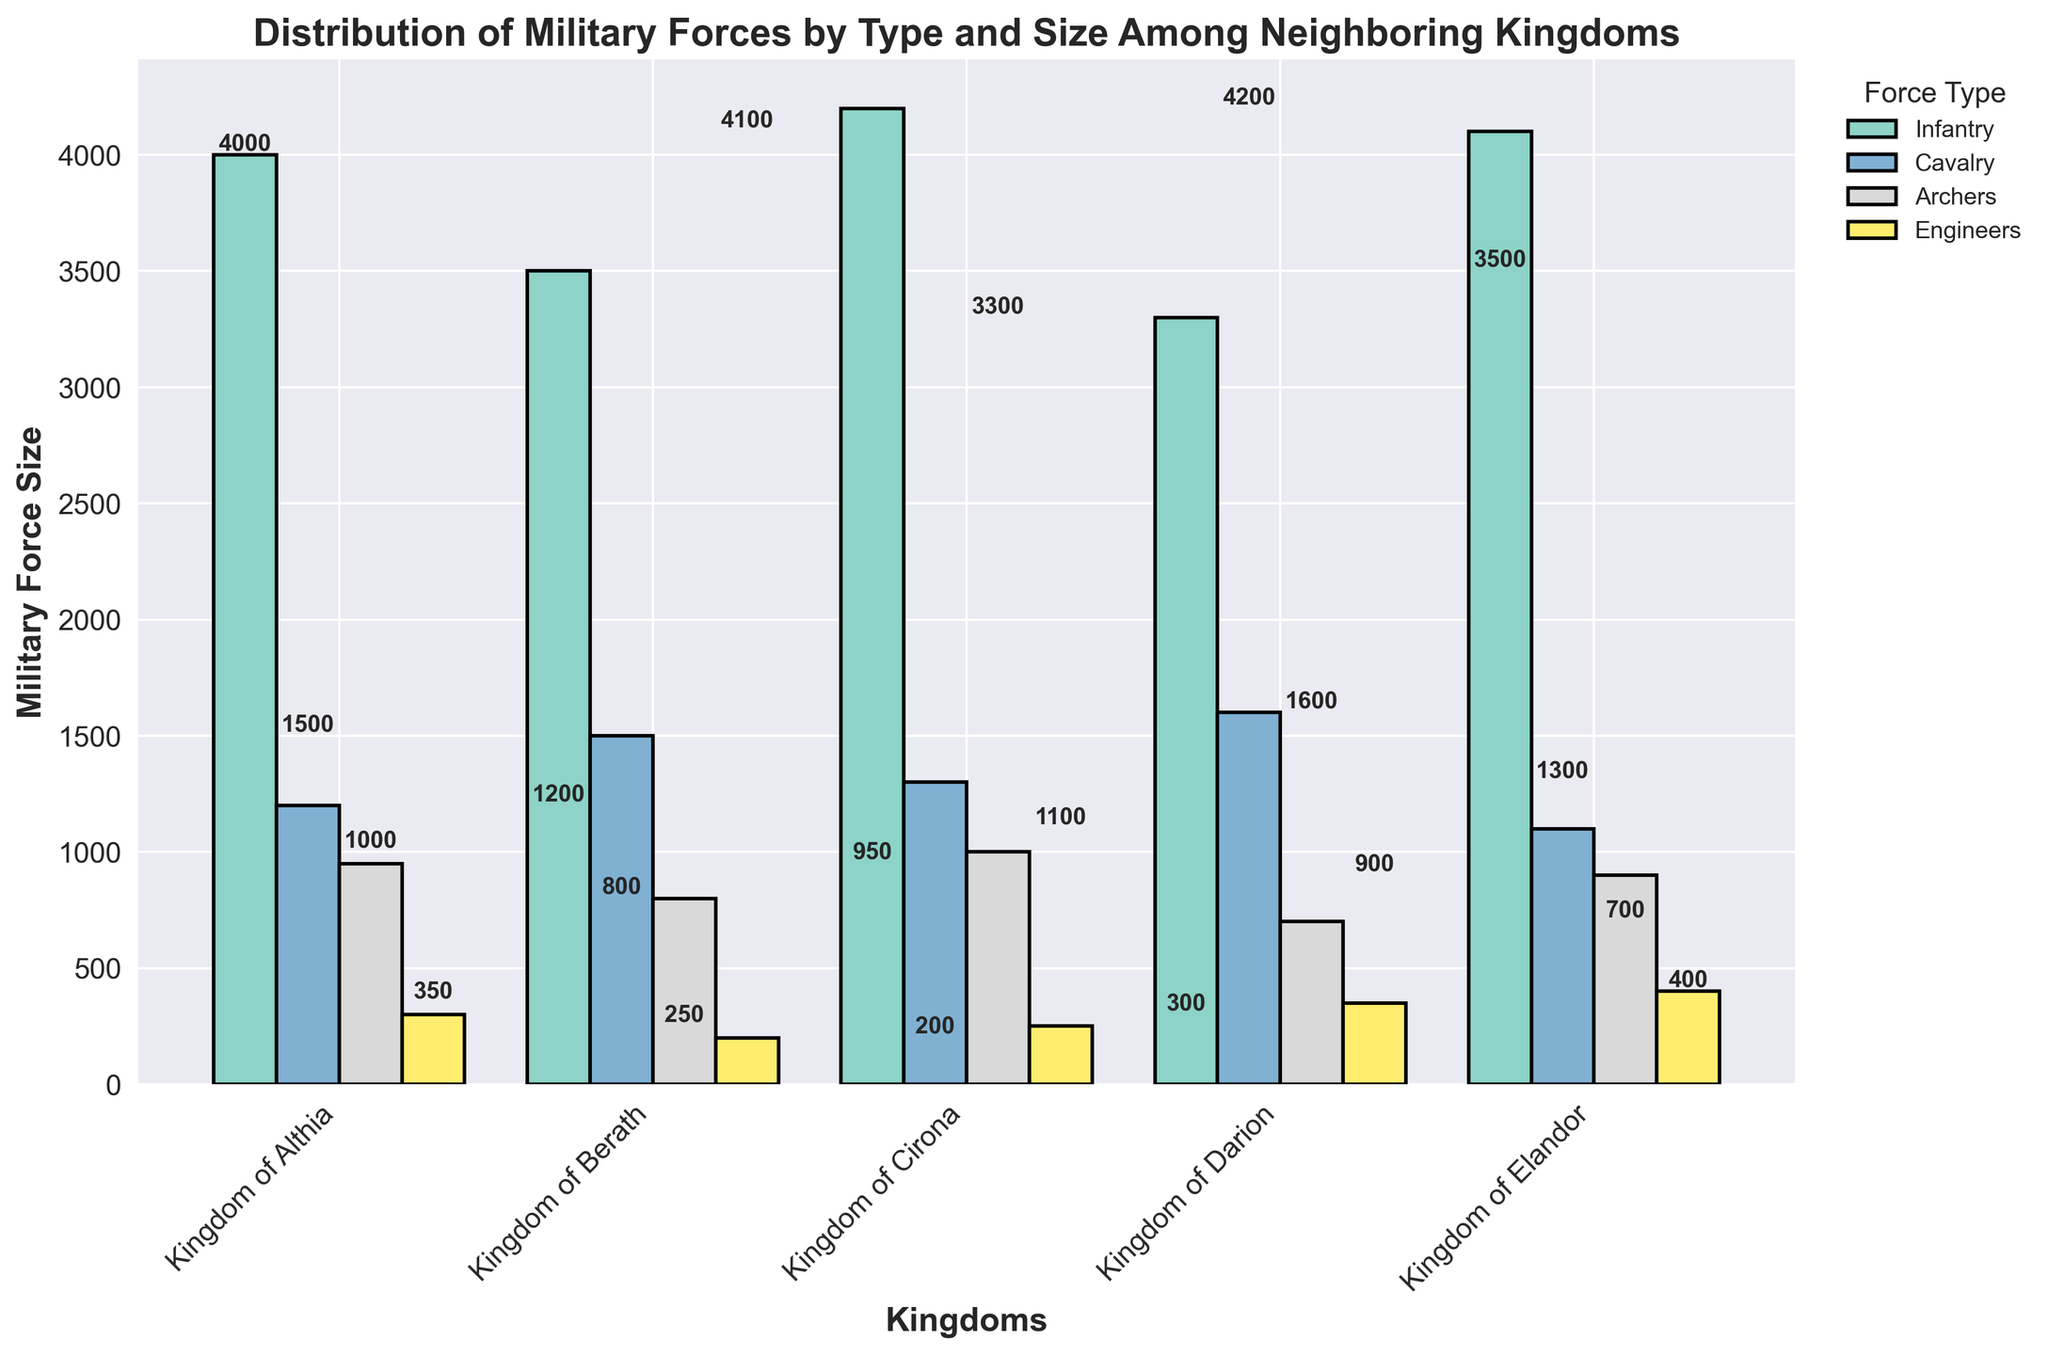Who has the largest infantry force? The largest bars are for each kingdom's infantry. The Kingdom of Cirona has the largest infantry force at 4200.
Answer: Kingdom of Cirona How many archers are there in the Kingdom of Berath? Each type of military force is shown distinctly. The archers in the Kingdom of Berath are listed as 800.
Answer: 800 Which kingdom has the smallest engineers' force? The smallest bars for engineers across all kingdoms show that the Kingdom of Berath has the smallest number of engineers at 200.
Answer: Kingdom of Berath What is the total size of the military forces in the Kingdom of Althia? Sum up the sizes of all forces in the Kingdom of Althia: Infantry (4000), Cavalry (1200), Archers (950), Engineers (300). Total = 4000 + 1200 + 950 + 300 = 6450.
Answer: 6450 Which type of military force is most abundant in the Kingdom of Darion? By comparing the heights of the bars representing different forces in Darion, Infantry stands the tallest at 3300.
Answer: Infantry Compare the cavalry forces of the Kingdom of Berath and the Kingdom of Elandor. Which is larger and by how much? The bar for Berath's cavalry is 1500 and for Elandor is 1100. Difference: 1500 - 1100 = 400.
Answer: Kingdom of Berath, 400 Which kingdom has the closest number of archers to 1000? Observing the bars for archers, the Kingdom of Cirona has exactly 1000 archers.
Answer: Kingdom of Cirona What is the average size of the cavalry forces across all kingdoms? Add the sizes of cavalry forces from all kingdoms: 1200 (Althia) + 1500 (Berath) + 1300 (Cirona) + 1600 (Darion) + 1100 (Elandor) = 6700. Then, divide by 5 kingdoms: 6700 / 5 = 1340.
Answer: 1340 By what percentage is the infantry force of the Kingdom of Berath smaller than that of Althia? Calculate the difference in infantry sizes: 4000 (Althia) - 3500 (Berath) = 500. Then, (500 / 4000) * 100 = 12.5%.
Answer: 12.5% Which force type in the Kingdom of Elandor has the least number of soldiers, and what is that number? The bar representing the Engineers in Elandor is the shortest, with 400 soldiers.
Answer: Engineers, 400 